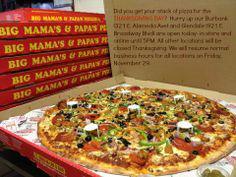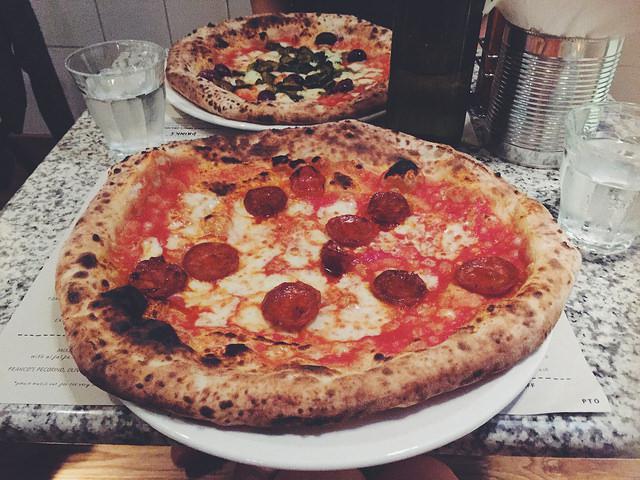The first image is the image on the left, the second image is the image on the right. For the images shown, is this caption "Both images contain pizza boxes." true? Answer yes or no. No. 